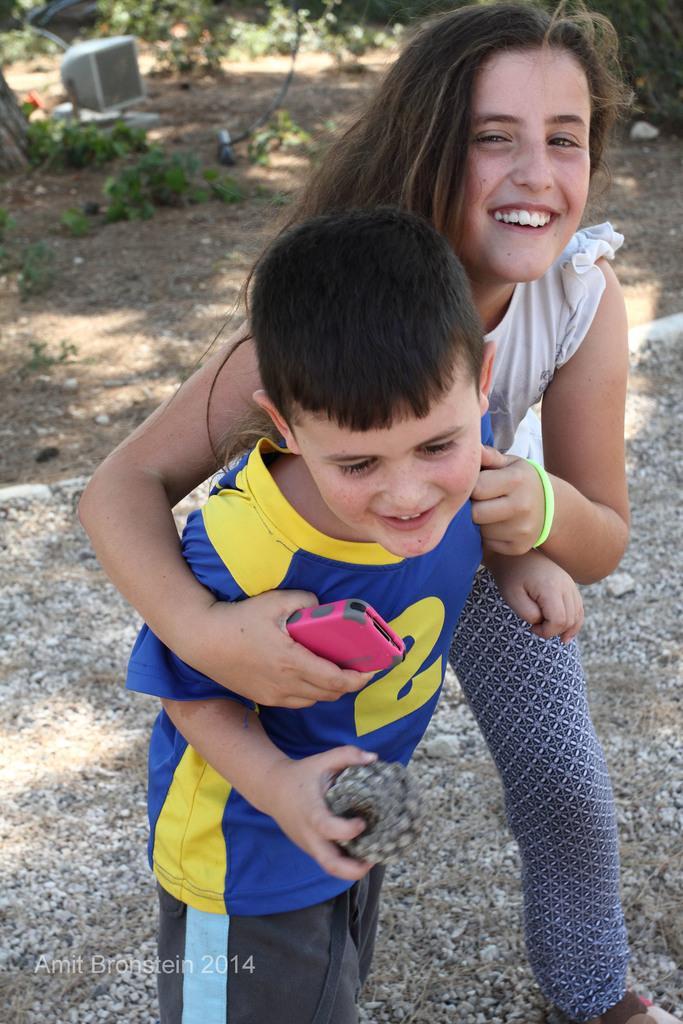Please provide a concise description of this image. In this image in the foreground there is one girl and one boy who are smiling, and both of them are holding something in their hands. In the background there is sand, walkway, plants and some object. 